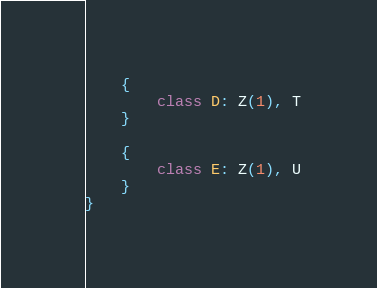<code> <loc_0><loc_0><loc_500><loc_500><_Kotlin_>
    {
        class D: Z(1), T
    }

    {
        class E: Z(1), U
    }
}</code> 